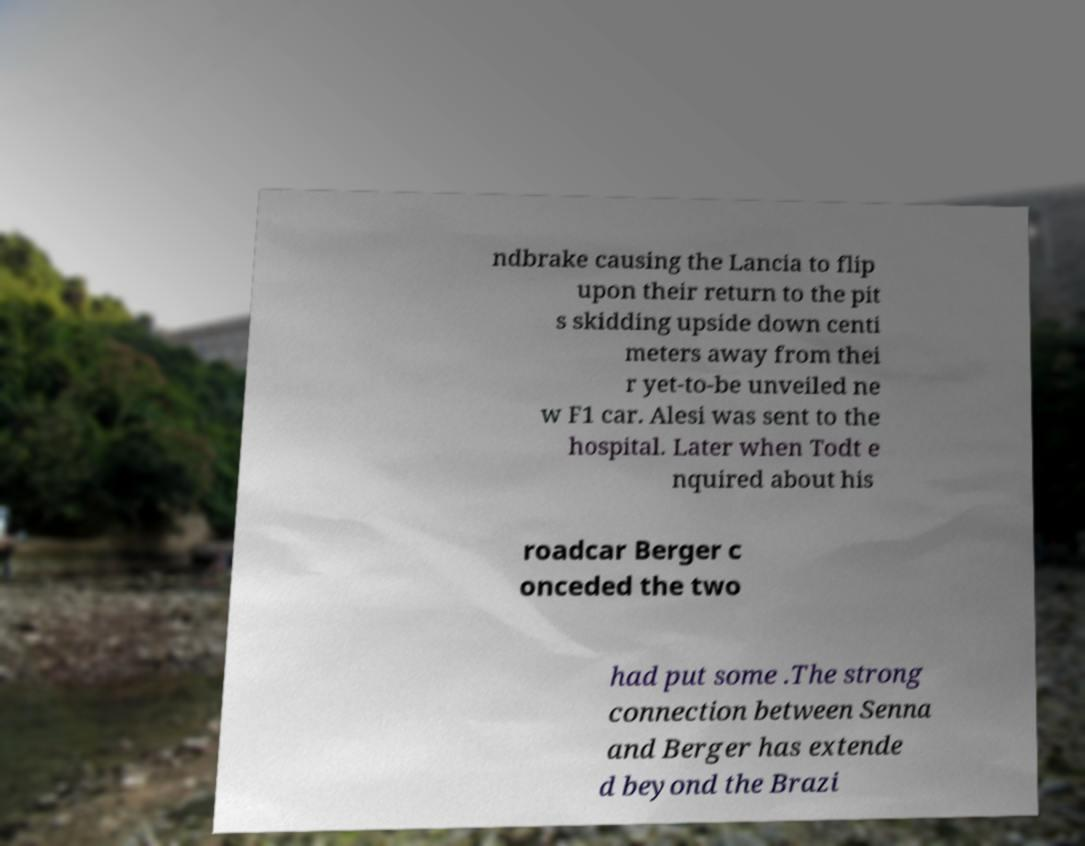Could you extract and type out the text from this image? ndbrake causing the Lancia to flip upon their return to the pit s skidding upside down centi meters away from thei r yet-to-be unveiled ne w F1 car. Alesi was sent to the hospital. Later when Todt e nquired about his roadcar Berger c onceded the two had put some .The strong connection between Senna and Berger has extende d beyond the Brazi 